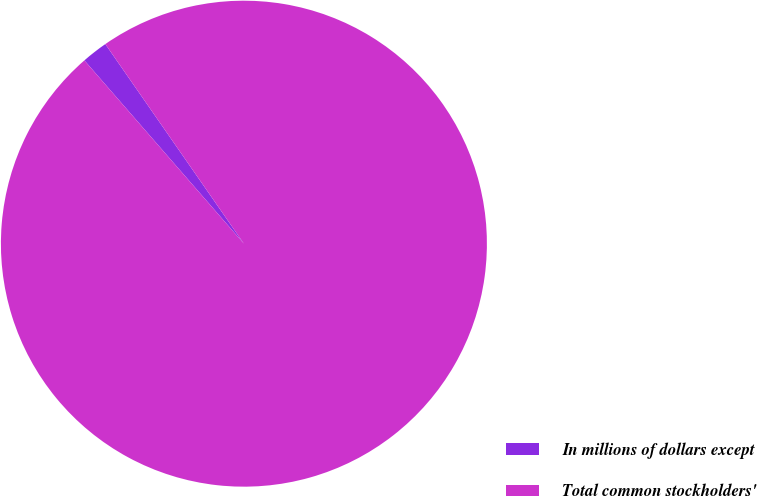<chart> <loc_0><loc_0><loc_500><loc_500><pie_chart><fcel>In millions of dollars except<fcel>Total common stockholders'<nl><fcel>1.74%<fcel>98.26%<nl></chart> 